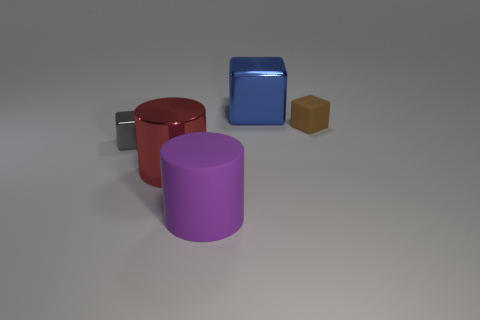Subtract all metallic blocks. How many blocks are left? 1 Add 1 tiny brown metal blocks. How many objects exist? 6 Subtract all blue blocks. How many blocks are left? 2 Subtract all blocks. How many objects are left? 2 Subtract 2 cubes. How many cubes are left? 1 Add 2 purple objects. How many purple objects exist? 3 Subtract 1 red cylinders. How many objects are left? 4 Subtract all gray cylinders. Subtract all cyan cubes. How many cylinders are left? 2 Subtract all purple cylinders. Subtract all blue metallic objects. How many objects are left? 3 Add 2 tiny rubber blocks. How many tiny rubber blocks are left? 3 